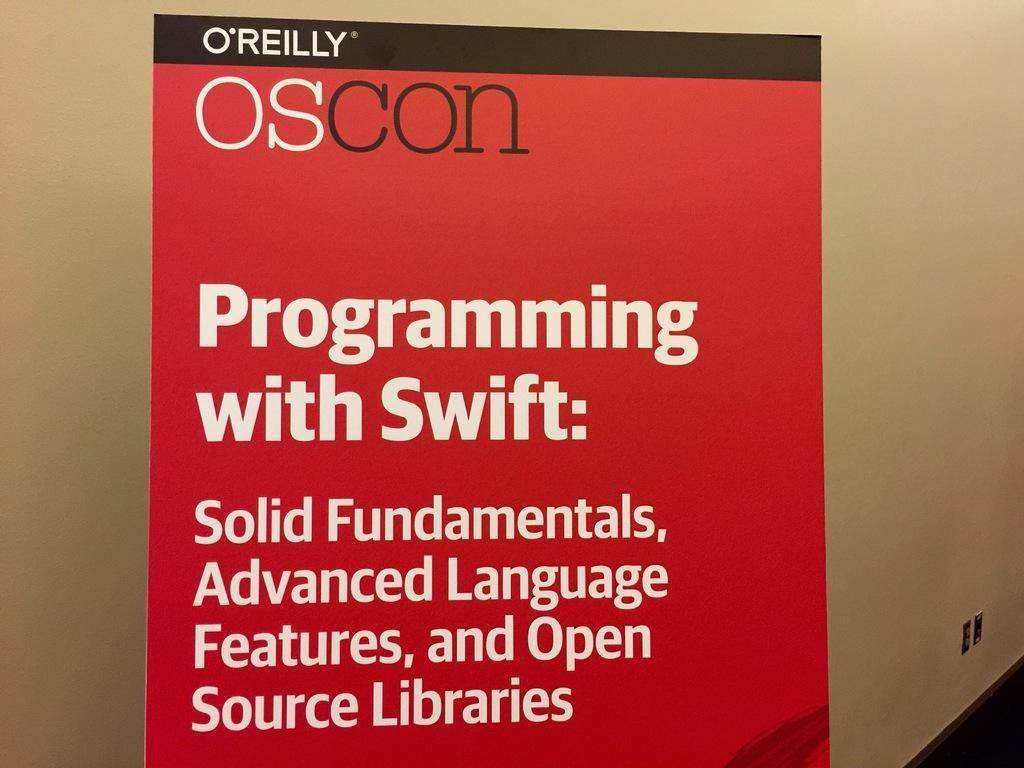<image>
Render a clear and concise summary of the photo. a red poster board with the heading "programming with swift" on it 